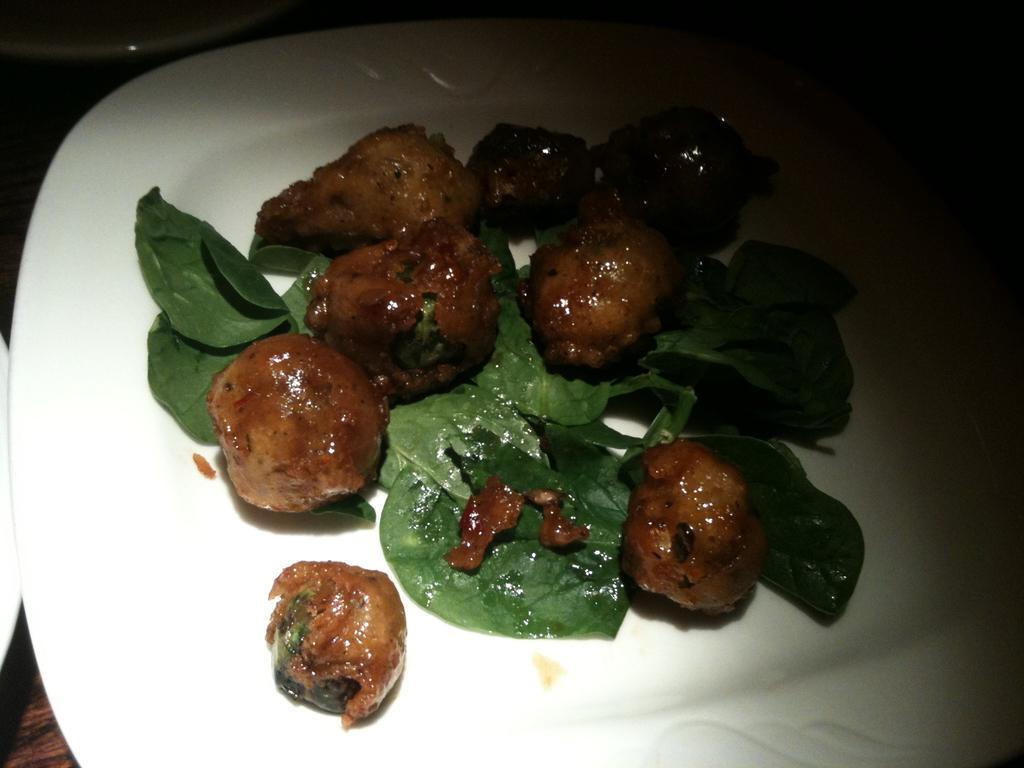Could you give a brief overview of what you see in this image? In this image there are food items on a plate, the plate is on a table. Beside the plate there are some other objects. 